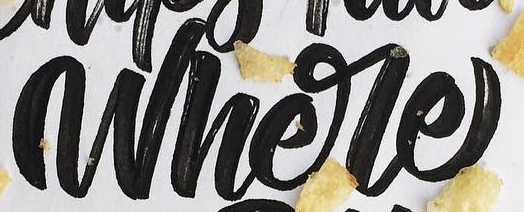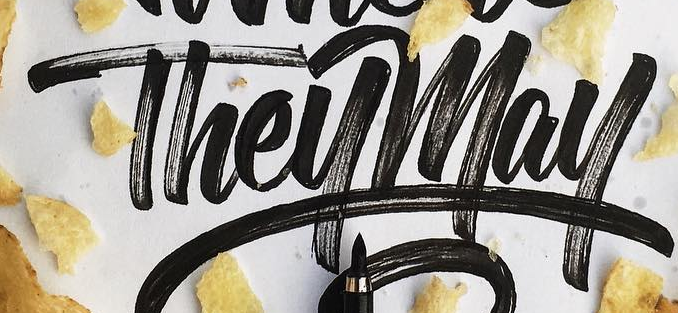Read the text from these images in sequence, separated by a semicolon. Where; Theymay 